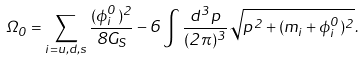<formula> <loc_0><loc_0><loc_500><loc_500>\Omega _ { 0 } = \sum _ { i = u , d , s } \frac { ( \phi ^ { 0 } _ { i } ) ^ { 2 } } { 8 G _ { S } } - 6 \int \frac { d ^ { 3 } p } { ( 2 \pi ) ^ { 3 } } \sqrt { p ^ { 2 } + ( m _ { i } + \phi ^ { 0 } _ { i } ) ^ { 2 } } .</formula> 